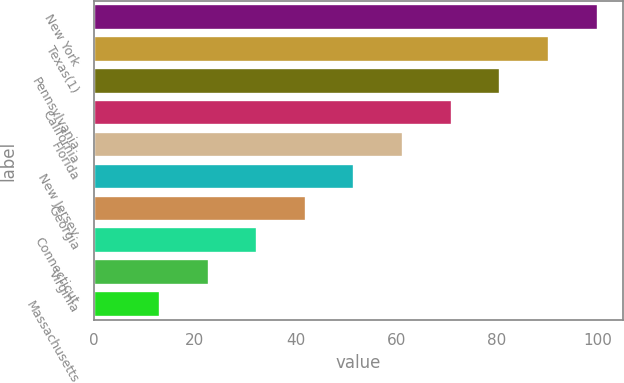Convert chart. <chart><loc_0><loc_0><loc_500><loc_500><bar_chart><fcel>New York<fcel>Texas(1)<fcel>Pennsylvania<fcel>California<fcel>Florida<fcel>New Jersey<fcel>Georgia<fcel>Connecticut<fcel>Virginia<fcel>Massachusetts<nl><fcel>100<fcel>90.34<fcel>80.68<fcel>71.02<fcel>61.36<fcel>51.7<fcel>42.04<fcel>32.38<fcel>22.72<fcel>13.06<nl></chart> 